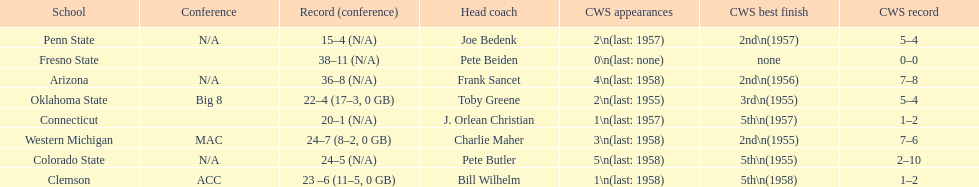Help me parse the entirety of this table. {'header': ['School', 'Conference', 'Record (conference)', 'Head coach', 'CWS appearances', 'CWS best finish', 'CWS record'], 'rows': [['Penn State', 'N/A', '15–4 (N/A)', 'Joe Bedenk', '2\\n(last: 1957)', '2nd\\n(1957)', '5–4'], ['Fresno State', '', '38–11 (N/A)', 'Pete Beiden', '0\\n(last: none)', 'none', '0–0'], ['Arizona', 'N/A', '36–8 (N/A)', 'Frank Sancet', '4\\n(last: 1958)', '2nd\\n(1956)', '7–8'], ['Oklahoma State', 'Big 8', '22–4 (17–3, 0 GB)', 'Toby Greene', '2\\n(last: 1955)', '3rd\\n(1955)', '5–4'], ['Connecticut', '', '20–1 (N/A)', 'J. Orlean Christian', '1\\n(last: 1957)', '5th\\n(1957)', '1–2'], ['Western Michigan', 'MAC', '24–7 (8–2, 0 GB)', 'Charlie Maher', '3\\n(last: 1958)', '2nd\\n(1955)', '7–6'], ['Colorado State', 'N/A', '24–5 (N/A)', 'Pete Butler', '5\\n(last: 1958)', '5th\\n(1955)', '2–10'], ['Clemson', 'ACC', '23 –6 (11–5, 0 GB)', 'Bill Wilhelm', '1\\n(last: 1958)', '5th\\n(1958)', '1–2']]} List the schools that came in last place in the cws best finish. Clemson, Colorado State, Connecticut. 